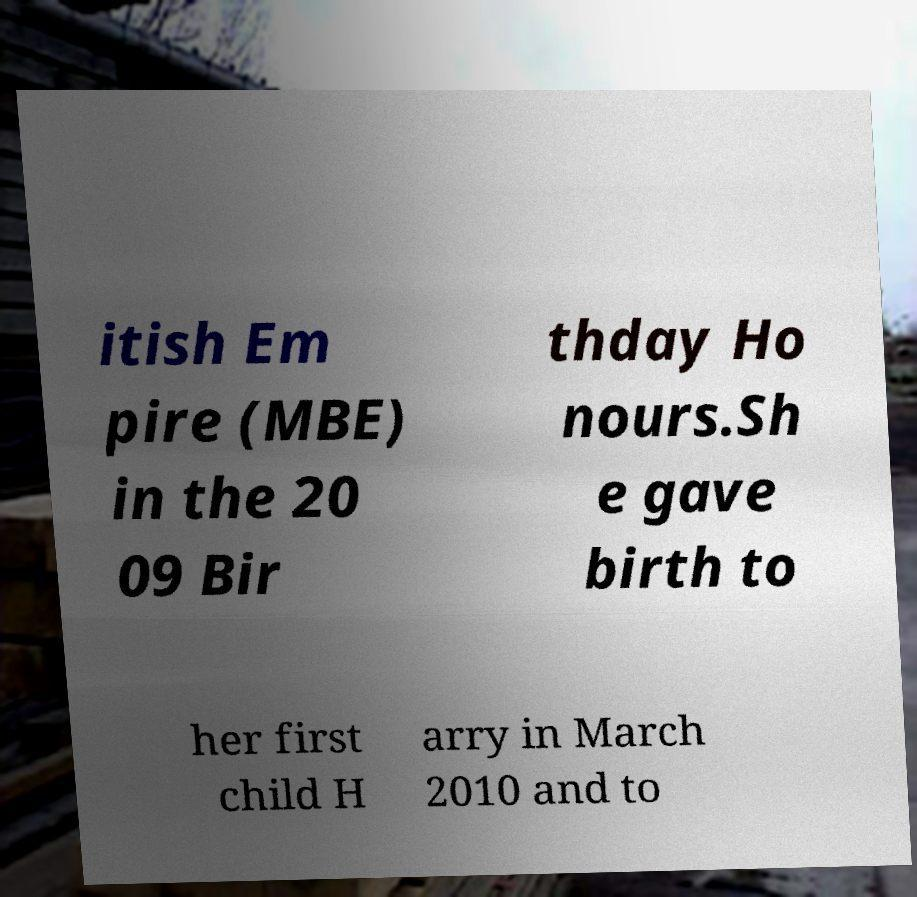Could you extract and type out the text from this image? itish Em pire (MBE) in the 20 09 Bir thday Ho nours.Sh e gave birth to her first child H arry in March 2010 and to 